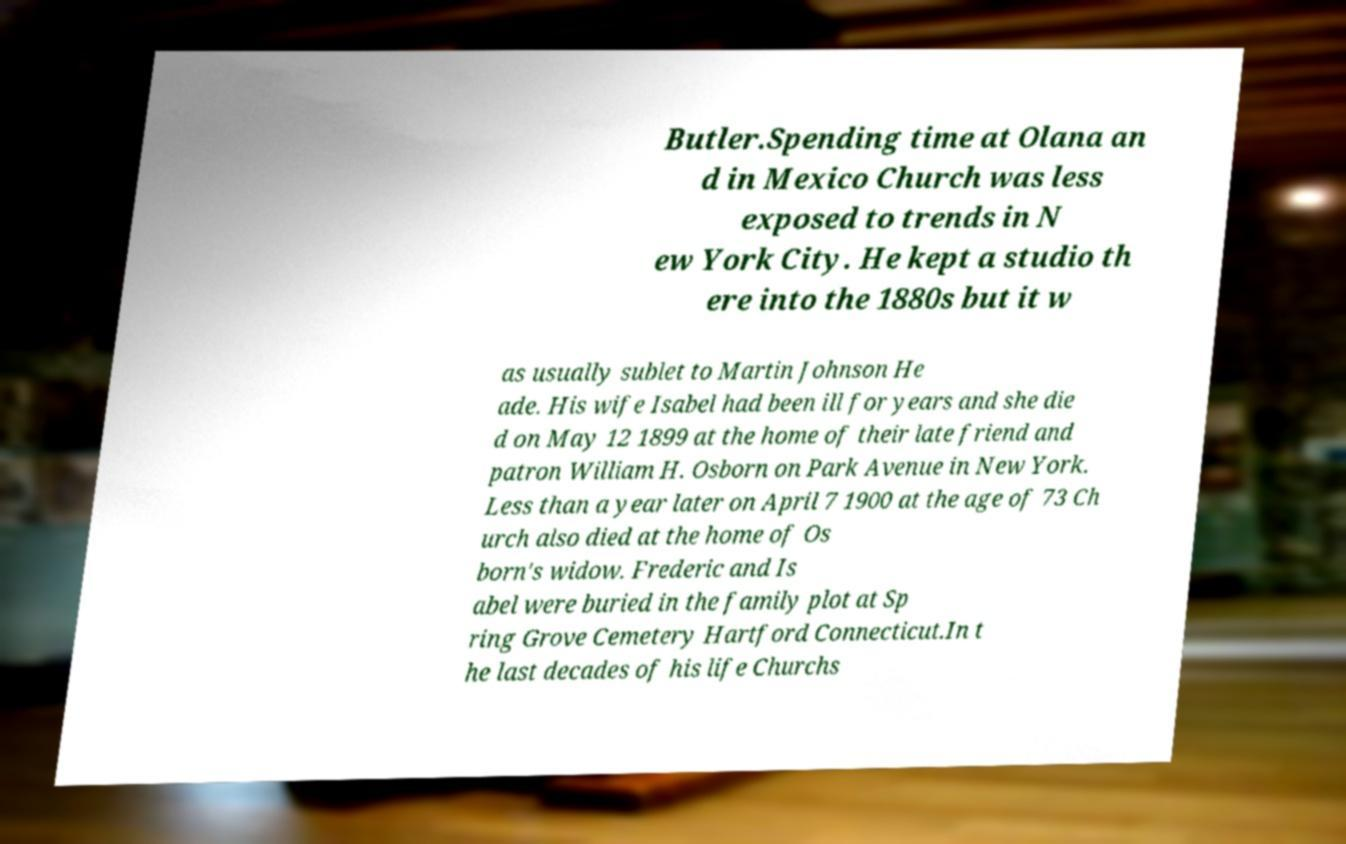Please identify and transcribe the text found in this image. Butler.Spending time at Olana an d in Mexico Church was less exposed to trends in N ew York City. He kept a studio th ere into the 1880s but it w as usually sublet to Martin Johnson He ade. His wife Isabel had been ill for years and she die d on May 12 1899 at the home of their late friend and patron William H. Osborn on Park Avenue in New York. Less than a year later on April 7 1900 at the age of 73 Ch urch also died at the home of Os born's widow. Frederic and Is abel were buried in the family plot at Sp ring Grove Cemetery Hartford Connecticut.In t he last decades of his life Churchs 